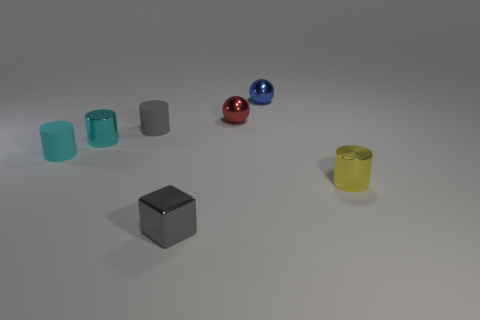Subtract 1 cylinders. How many cylinders are left? 3 Add 1 tiny gray blocks. How many objects exist? 8 Subtract all spheres. How many objects are left? 5 Add 5 small gray things. How many small gray things are left? 7 Add 2 small cyan matte objects. How many small cyan matte objects exist? 3 Subtract 0 red cylinders. How many objects are left? 7 Subtract all big balls. Subtract all yellow things. How many objects are left? 6 